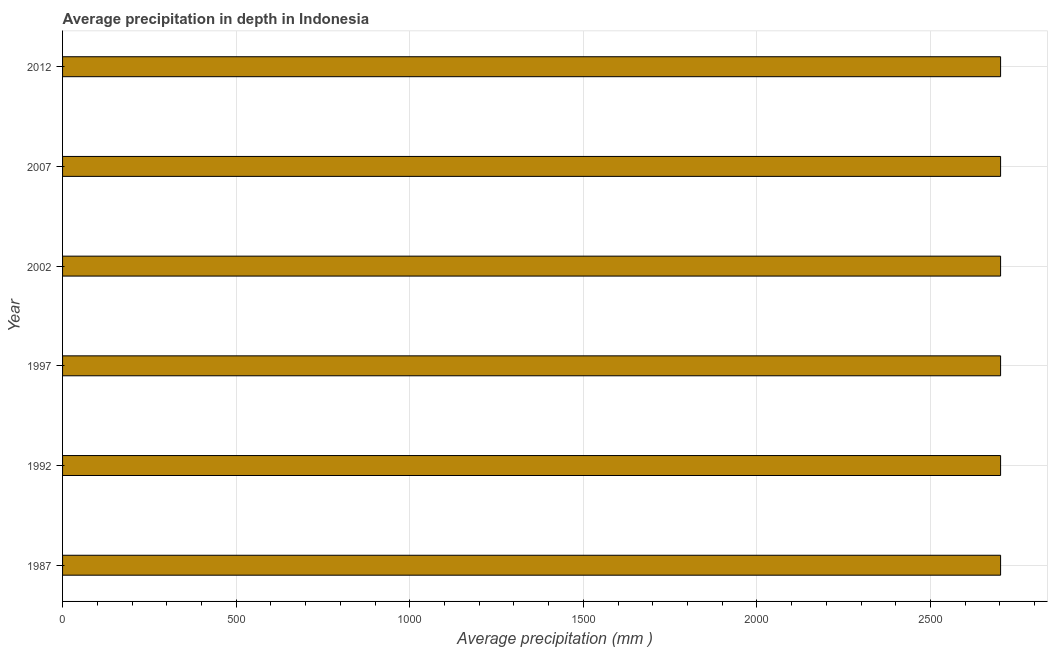Does the graph contain grids?
Ensure brevity in your answer.  Yes. What is the title of the graph?
Your answer should be very brief. Average precipitation in depth in Indonesia. What is the label or title of the X-axis?
Your answer should be compact. Average precipitation (mm ). What is the average precipitation in depth in 2007?
Provide a short and direct response. 2702. Across all years, what is the maximum average precipitation in depth?
Ensure brevity in your answer.  2702. Across all years, what is the minimum average precipitation in depth?
Offer a very short reply. 2702. What is the sum of the average precipitation in depth?
Ensure brevity in your answer.  1.62e+04. What is the average average precipitation in depth per year?
Give a very brief answer. 2702. What is the median average precipitation in depth?
Provide a short and direct response. 2702. In how many years, is the average precipitation in depth greater than 300 mm?
Your response must be concise. 6. Do a majority of the years between 1987 and 2007 (inclusive) have average precipitation in depth greater than 1300 mm?
Provide a succinct answer. Yes. What is the difference between two consecutive major ticks on the X-axis?
Provide a succinct answer. 500. What is the Average precipitation (mm ) in 1987?
Offer a very short reply. 2702. What is the Average precipitation (mm ) in 1992?
Provide a short and direct response. 2702. What is the Average precipitation (mm ) of 1997?
Offer a very short reply. 2702. What is the Average precipitation (mm ) in 2002?
Keep it short and to the point. 2702. What is the Average precipitation (mm ) in 2007?
Offer a terse response. 2702. What is the Average precipitation (mm ) in 2012?
Your response must be concise. 2702. What is the difference between the Average precipitation (mm ) in 1987 and 1997?
Keep it short and to the point. 0. What is the difference between the Average precipitation (mm ) in 1987 and 2007?
Give a very brief answer. 0. What is the difference between the Average precipitation (mm ) in 1987 and 2012?
Keep it short and to the point. 0. What is the difference between the Average precipitation (mm ) in 1992 and 1997?
Provide a short and direct response. 0. What is the difference between the Average precipitation (mm ) in 1992 and 2002?
Keep it short and to the point. 0. What is the difference between the Average precipitation (mm ) in 1997 and 2012?
Make the answer very short. 0. What is the ratio of the Average precipitation (mm ) in 1987 to that in 1992?
Provide a succinct answer. 1. What is the ratio of the Average precipitation (mm ) in 1992 to that in 1997?
Keep it short and to the point. 1. What is the ratio of the Average precipitation (mm ) in 1997 to that in 2007?
Offer a terse response. 1. What is the ratio of the Average precipitation (mm ) in 1997 to that in 2012?
Your response must be concise. 1. What is the ratio of the Average precipitation (mm ) in 2002 to that in 2007?
Offer a terse response. 1. What is the ratio of the Average precipitation (mm ) in 2002 to that in 2012?
Provide a short and direct response. 1. 